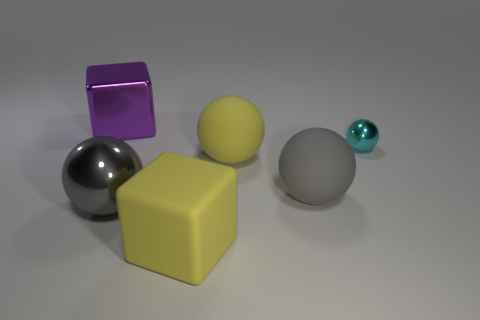What is the material of the other yellow thing that is the same shape as the small object?
Your answer should be compact. Rubber. Is there any other thing that is the same material as the yellow sphere?
Ensure brevity in your answer.  Yes. Is the number of objects on the left side of the purple thing the same as the number of gray rubber balls behind the large yellow matte sphere?
Offer a very short reply. Yes. Does the tiny ball have the same material as the purple block?
Your answer should be very brief. Yes. What number of purple things are big cubes or big spheres?
Your answer should be very brief. 1. What number of big gray shiny things are the same shape as the tiny thing?
Provide a short and direct response. 1. What is the material of the purple thing?
Ensure brevity in your answer.  Metal. Are there an equal number of purple shiny objects left of the large shiny cube and small blue matte spheres?
Make the answer very short. Yes. What shape is the gray shiny object that is the same size as the metallic block?
Keep it short and to the point. Sphere. There is a block right of the large purple metal thing; are there any shiny things that are on the left side of it?
Provide a short and direct response. Yes. 